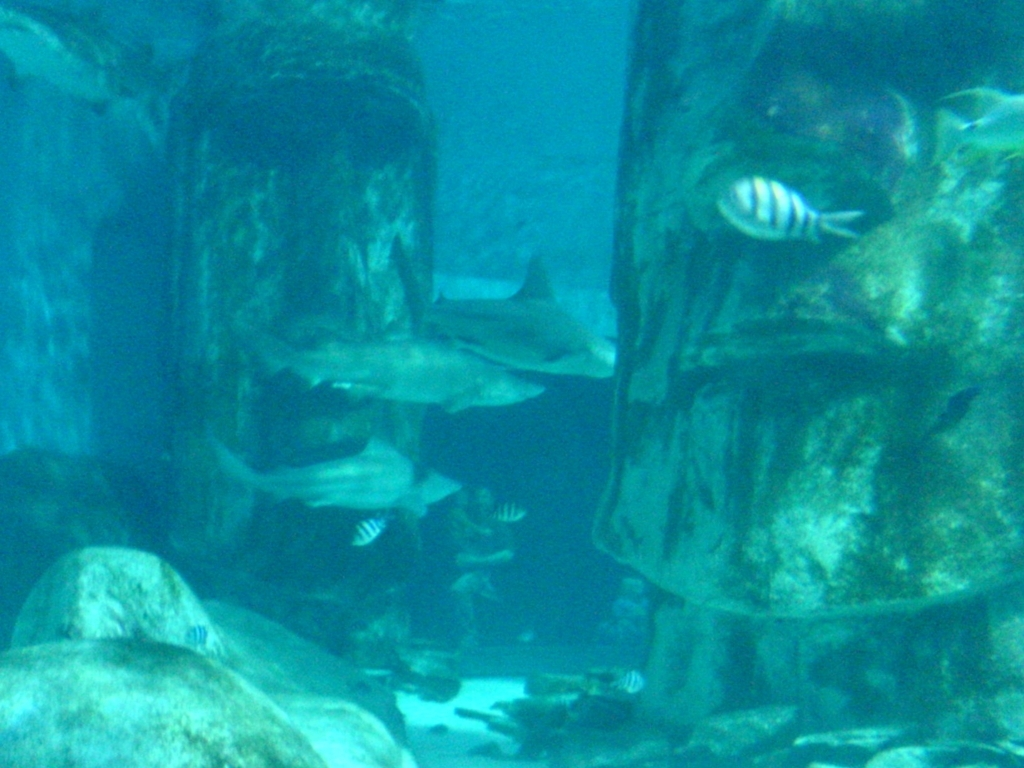Can you describe the environment shown in the picture? The environment in the image appears to be an artificial underwater habitat, perhaps part of an aquarium, with rocky structures designed to mimic a natural reef and provide shelter for fish and other marine life. What might be the purpose of taking this image? The purpose of such an image could be to document the aquatic life and the overall aesthetic of the artificial habitat, for educational purposes, to showcase biodiversity, or simply for the personal enjoyment of the photographer and viewers interested in marine ecosystems. 